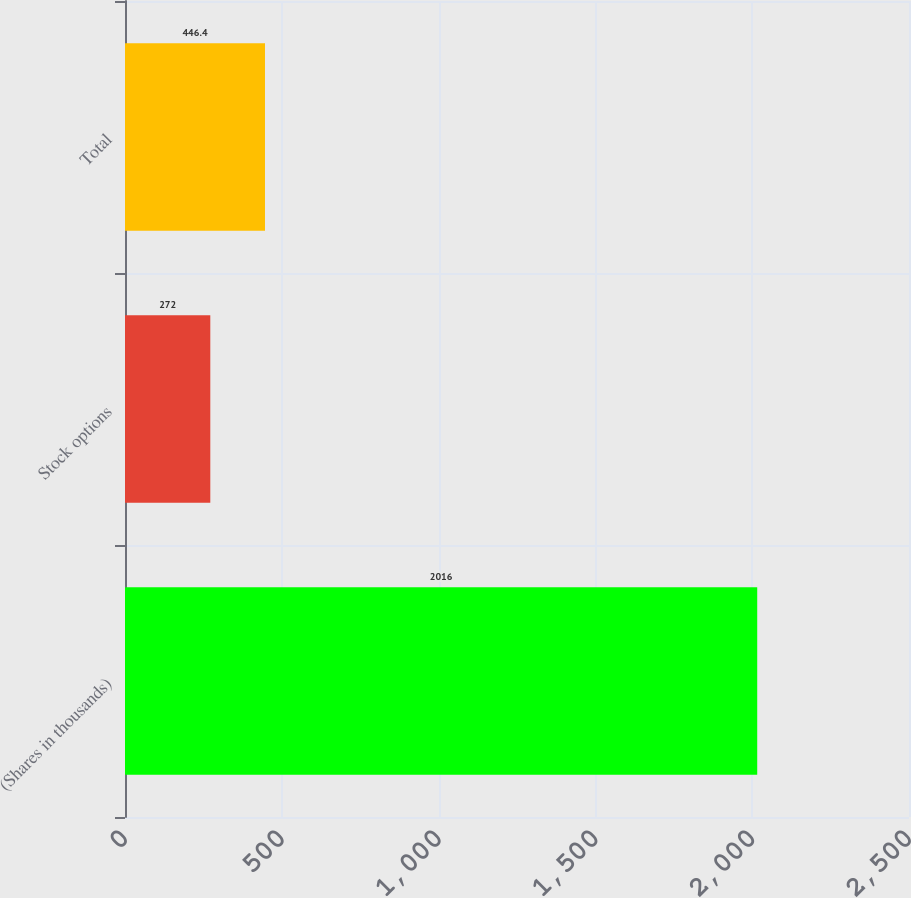Convert chart. <chart><loc_0><loc_0><loc_500><loc_500><bar_chart><fcel>(Shares in thousands)<fcel>Stock options<fcel>Total<nl><fcel>2016<fcel>272<fcel>446.4<nl></chart> 